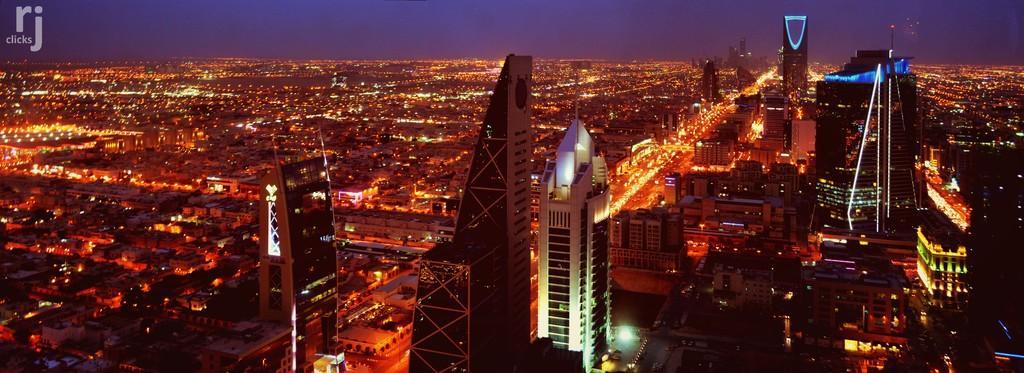How would you summarize this image in a sentence or two? This is the Aerial view, there are some buildings and there are some homes and there are some lights. 